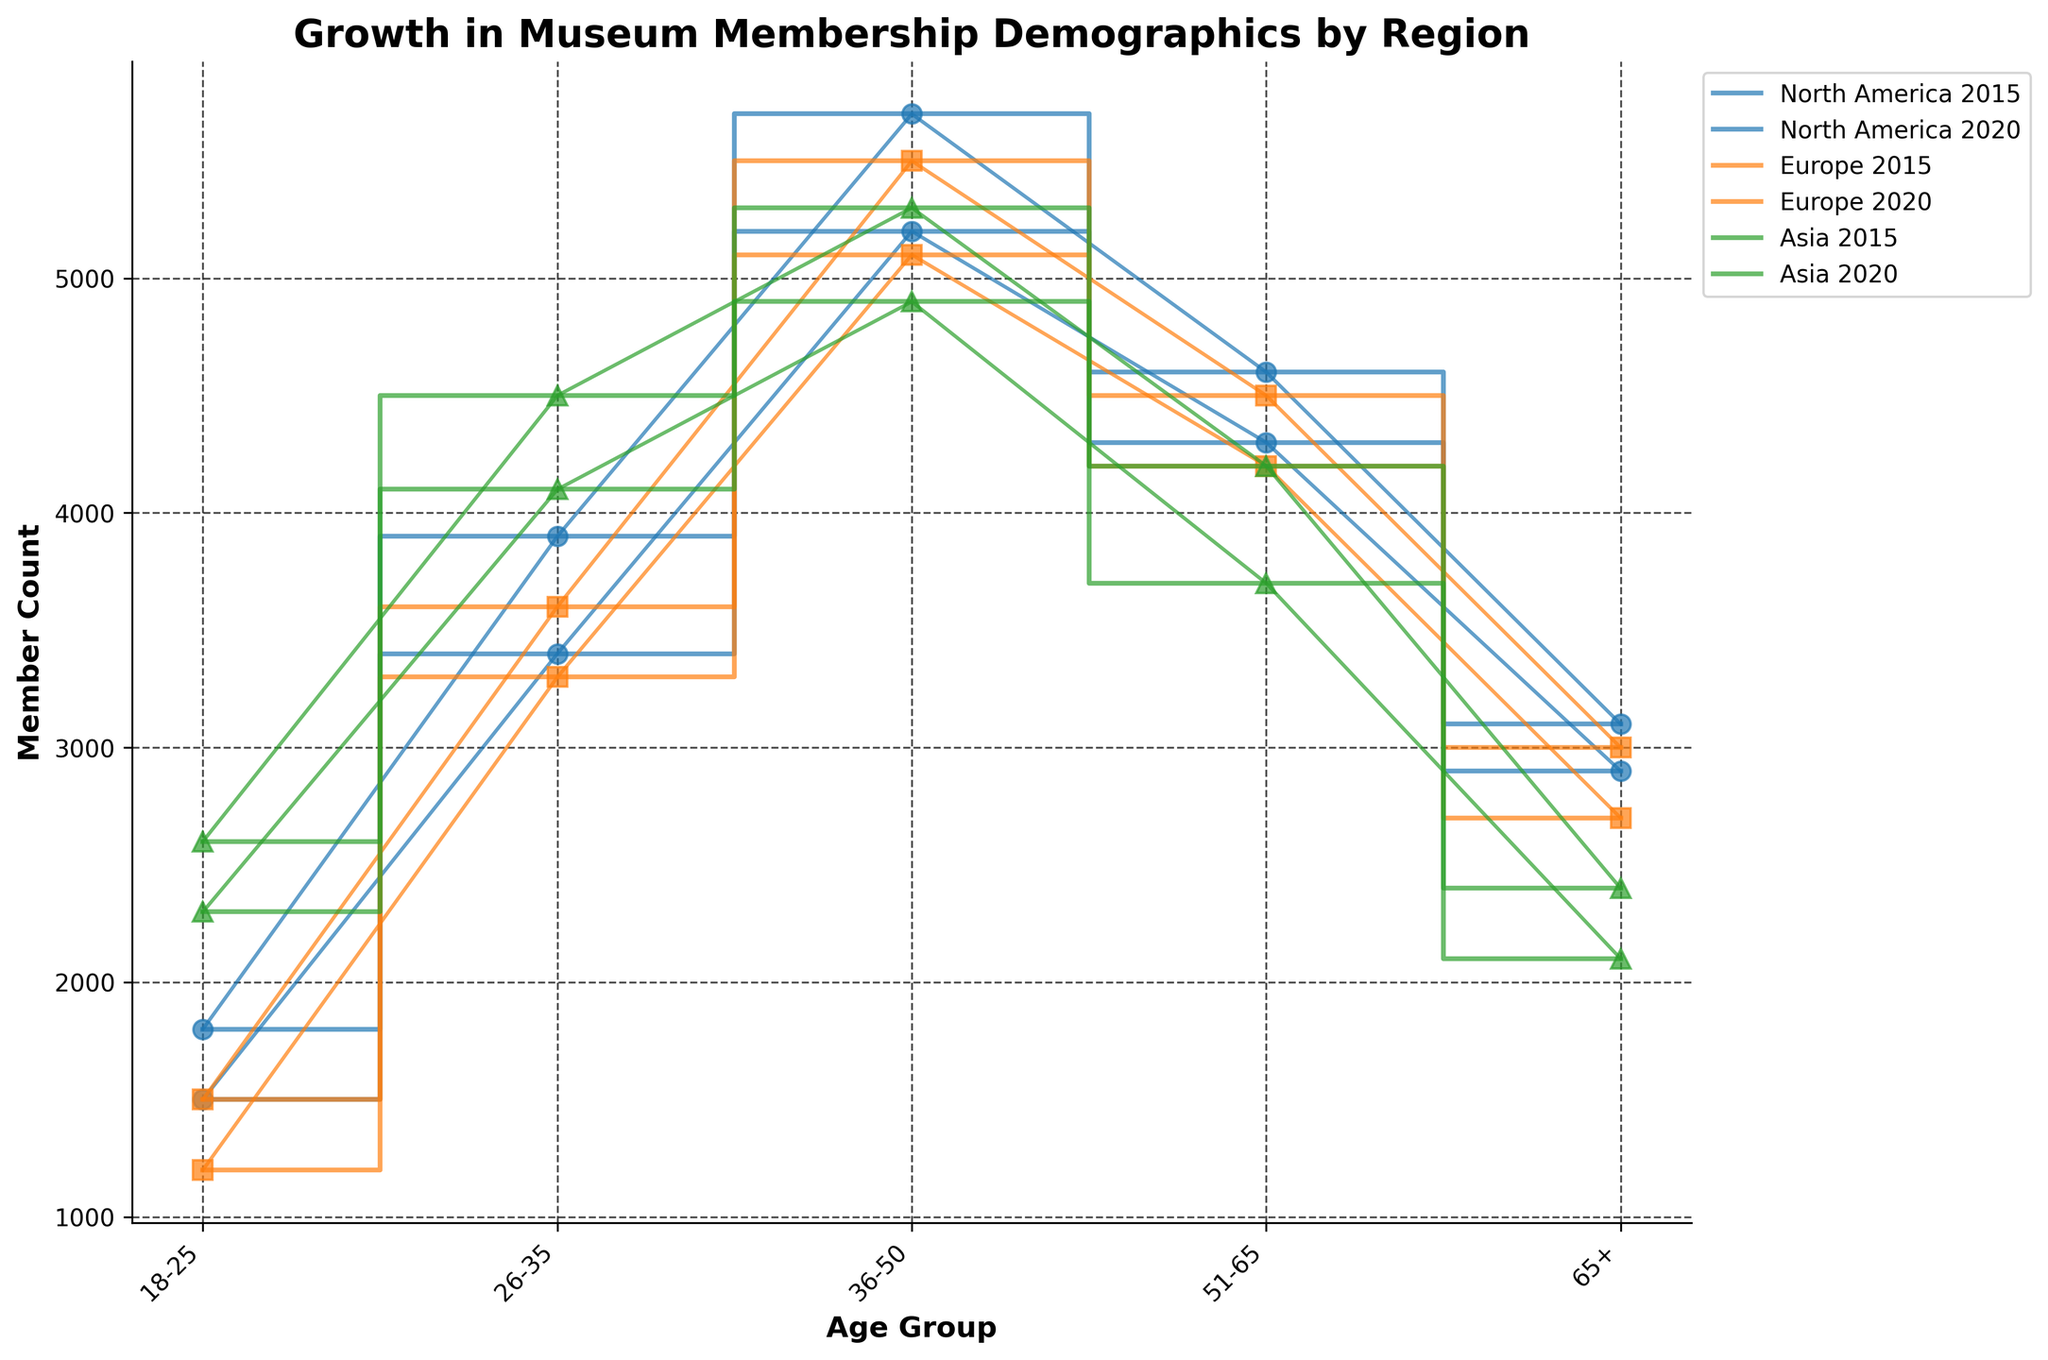What's the title of the figure? The title of the figure is located at the top center of the plot and summarizes the main topic of the chart.
Answer: Growth in Museum Membership Demographics by Region Which region shows the greatest increase in museum members in the 18-25 age group from 2015 to 2020? To find the greatest increase, subtract the 2015 member count from the 2020 member count for each region: North America (1800-1500 = 300), Europe (1500-1200 = 300), and Asia (2600-2300 = 300). All regions show an increase of 300 members.
Answer: All regions show equal increase What is the member count for the 36-50 age group in Europe in 2020? Locate the data point for Europe in 2020 on the x-axis labeled '36-50' and read the corresponding y-axis value.
Answer: 5500 Which region had the highest member count in 2015 for the 26-35 age group? Compare the heights of the bars (y-values) for the 26-35 age group in 2015 across all regions. North America has the tallest bar.
Answer: North America For the 51-65 age group in North America, how many more members were there in 2020 compared to 2015? Subtract the member count in 2015 (4300) from the count in 2020 (4600) to find the increase.
Answer: 300 Which region had the least growth in the 65+ age group between 2015 and 2020? Subtract the 2015 member count from the 2020 member count for each region: North America (3100-2900 = 200), Europe (3000-2700 = 300), Asia (2400-2100 = 300). North America had the least growth.
Answer: North America Describe the trend in membership for the 26-35 age group in Asia from 2015 to 2020. Observing the plot, the membership count for the 26-35 age group in Asia increased from 4100 in 2015 to 4500 in 2020.
Answer: Increasing trend Which age group shows the largest increase in membership across all regions from 2015 to 2020? Calculate the difference in member count for each age group across all regions and find the largest increase: 18-25 (300 each), 26-35 (500 in North America, 300 in Europe, 400 in Asia), 36-50 (500 North America, 400 Europe, 400 Asia), 51-65 (300 North America, 300 Europe, 500 Asia), 65+ (200 North America, 300 Europe, 300 Asia). The 26-35 age group in North America shows the largest increase.
Answer: 26-35 age group in North America 